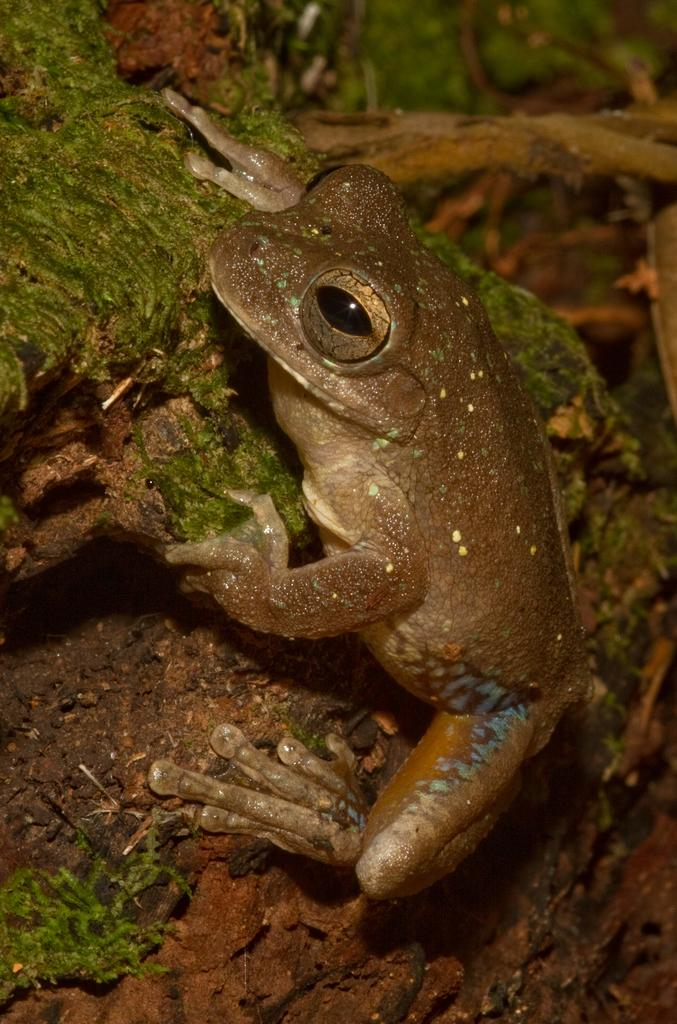What animal is present in the image? There is a frog in the image. Where is the frog located? The frog is on a rock. What type of vegetation can be seen in the image? There is grass visible in the image. What is the color of the grass? The grass is green in color. How does the frog express its feeling in the image? The image does not show the frog expressing any feelings, as it is a still image and does not depict emotions. 